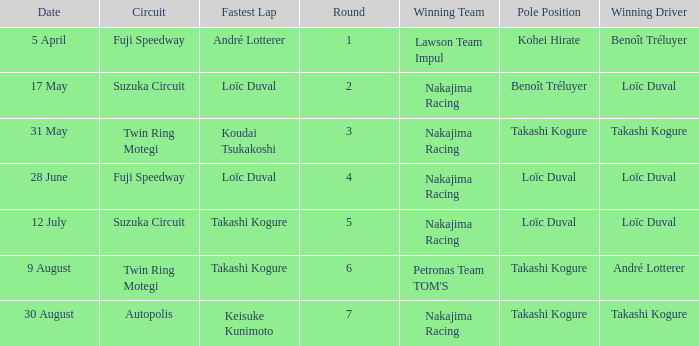What was the earlier round where Takashi Kogure got the fastest lap? 5.0. 